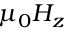<formula> <loc_0><loc_0><loc_500><loc_500>\mu _ { 0 } H _ { z }</formula> 